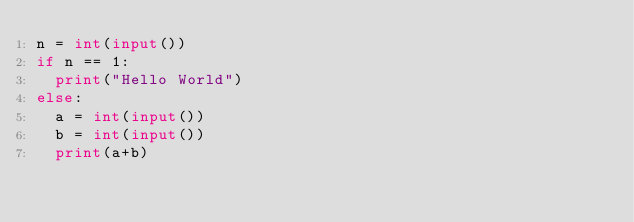<code> <loc_0><loc_0><loc_500><loc_500><_Python_>n = int(input())
if n == 1:
  print("Hello World")
else:
  a = int(input())
  b = int(input())
  print(a+b)</code> 